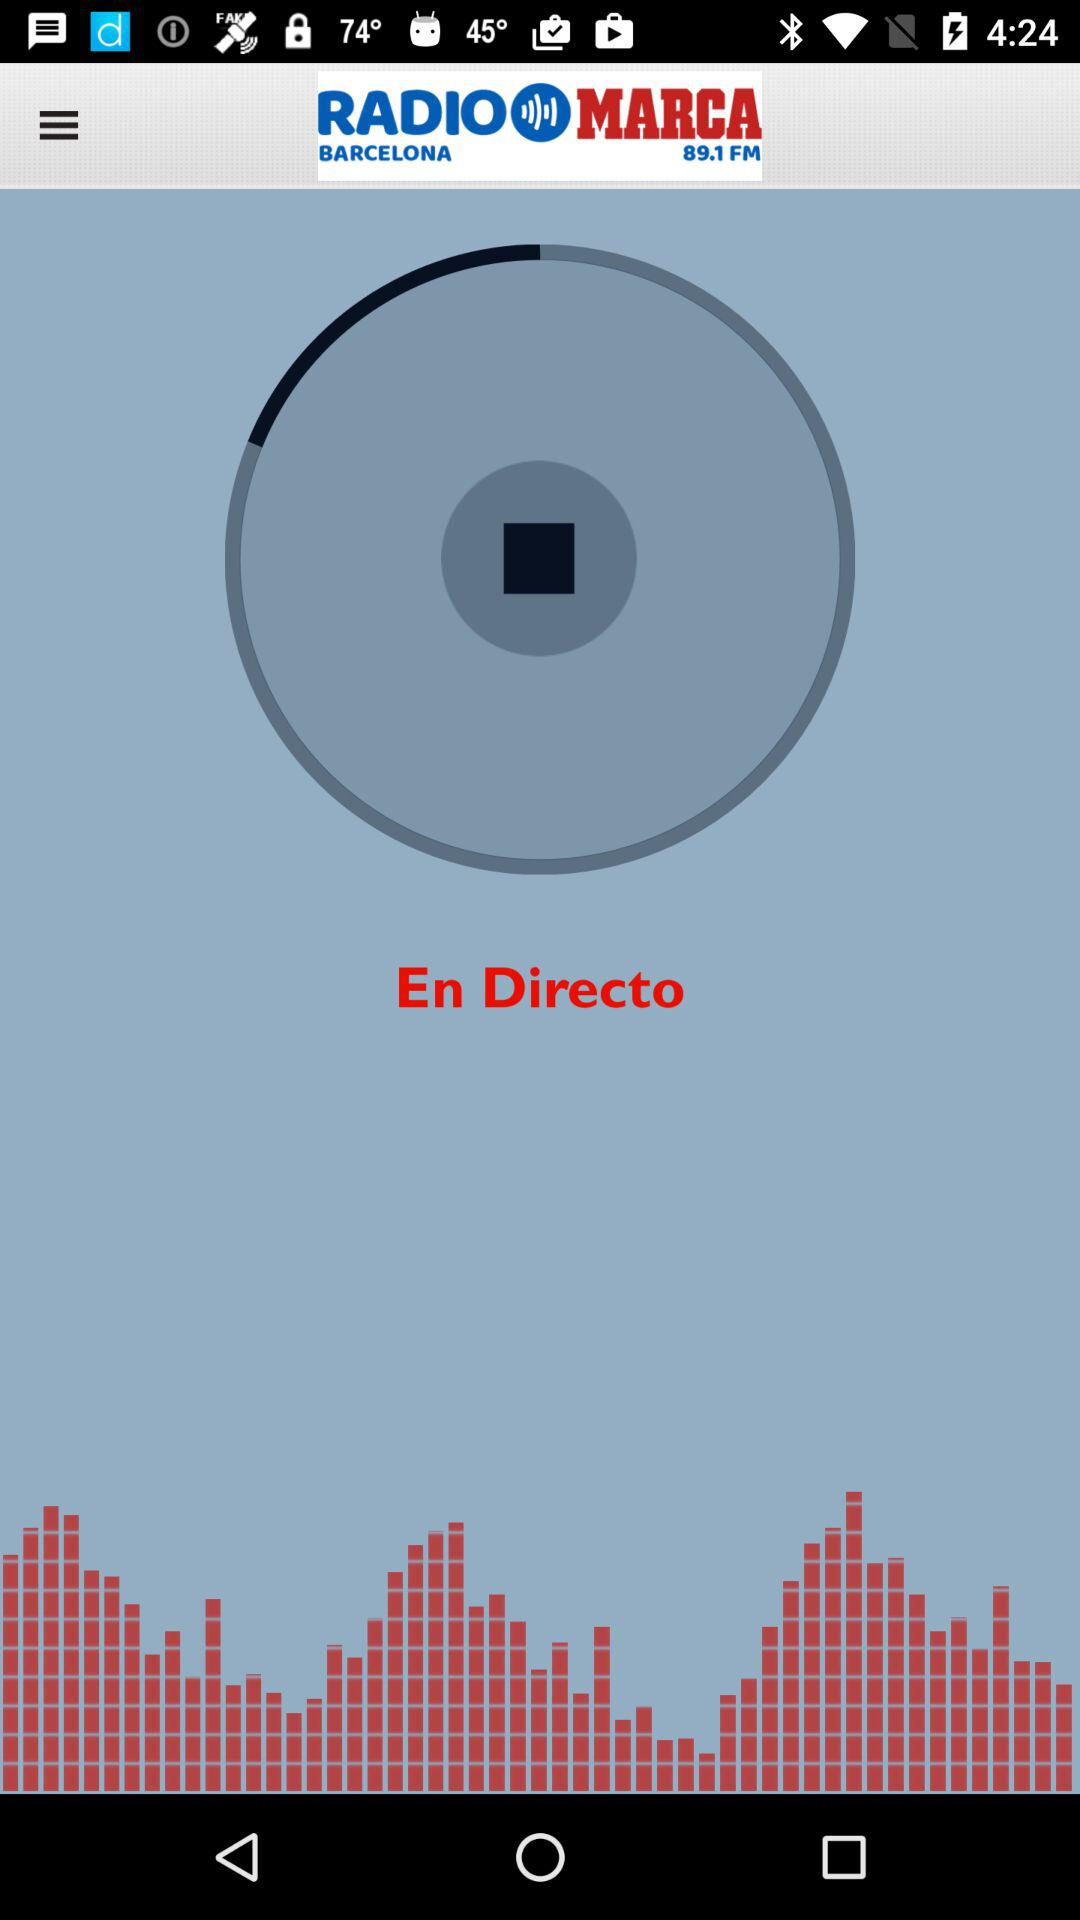What is the name of the application? The name of the application is "RADIO MARCA BARCELONA 89.1 FM". 